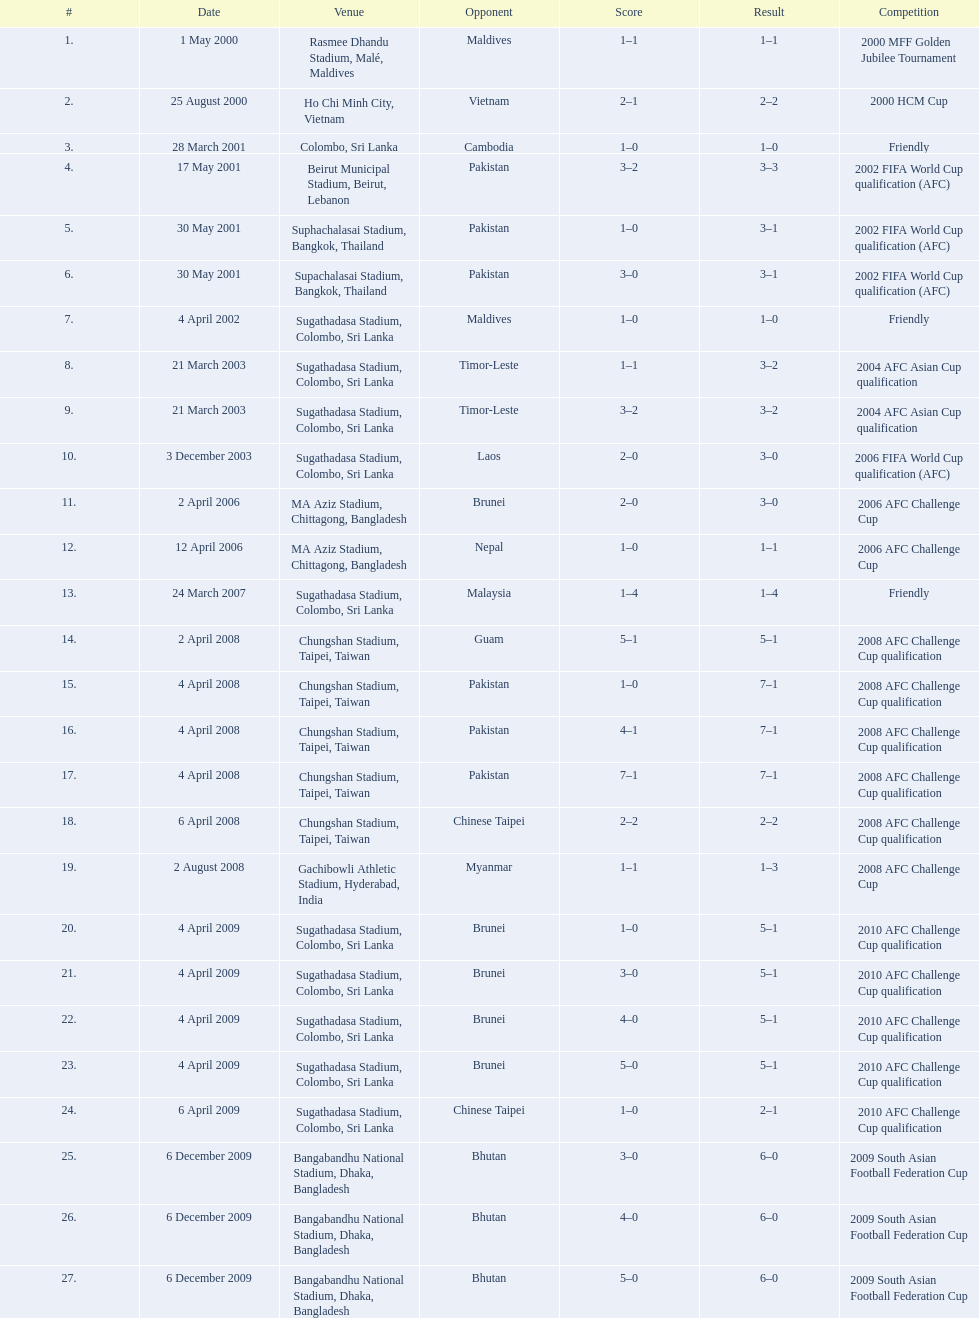What venues are listed? Rasmee Dhandu Stadium, Malé, Maldives, Ho Chi Minh City, Vietnam, Colombo, Sri Lanka, Beirut Municipal Stadium, Beirut, Lebanon, Suphachalasai Stadium, Bangkok, Thailand, MA Aziz Stadium, Chittagong, Bangladesh, Sugathadasa Stadium, Colombo, Sri Lanka, Chungshan Stadium, Taipei, Taiwan, Gachibowli Athletic Stadium, Hyderabad, India, Sugathadasa Stadium, Colombo, Sri Lanka, Bangabandhu National Stadium, Dhaka, Bangladesh. Which is top listed? Rasmee Dhandu Stadium, Malé, Maldives. 